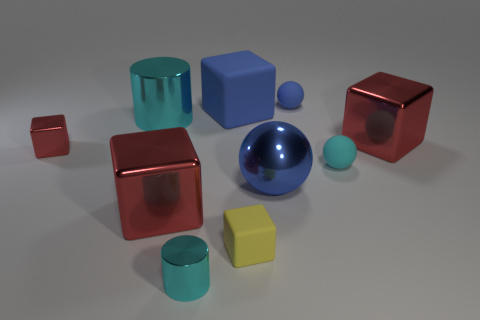How many red blocks must be subtracted to get 1 red blocks? 2 Subtract all yellow balls. How many red blocks are left? 3 Subtract 1 blocks. How many blocks are left? 4 Subtract all large blue blocks. How many blocks are left? 4 Subtract all cyan blocks. Subtract all brown cylinders. How many blocks are left? 5 Subtract all spheres. How many objects are left? 7 Add 9 large metallic cylinders. How many large metallic cylinders exist? 10 Subtract 0 purple cylinders. How many objects are left? 10 Subtract all tiny red metallic cubes. Subtract all tiny brown metal blocks. How many objects are left? 9 Add 4 small cylinders. How many small cylinders are left? 5 